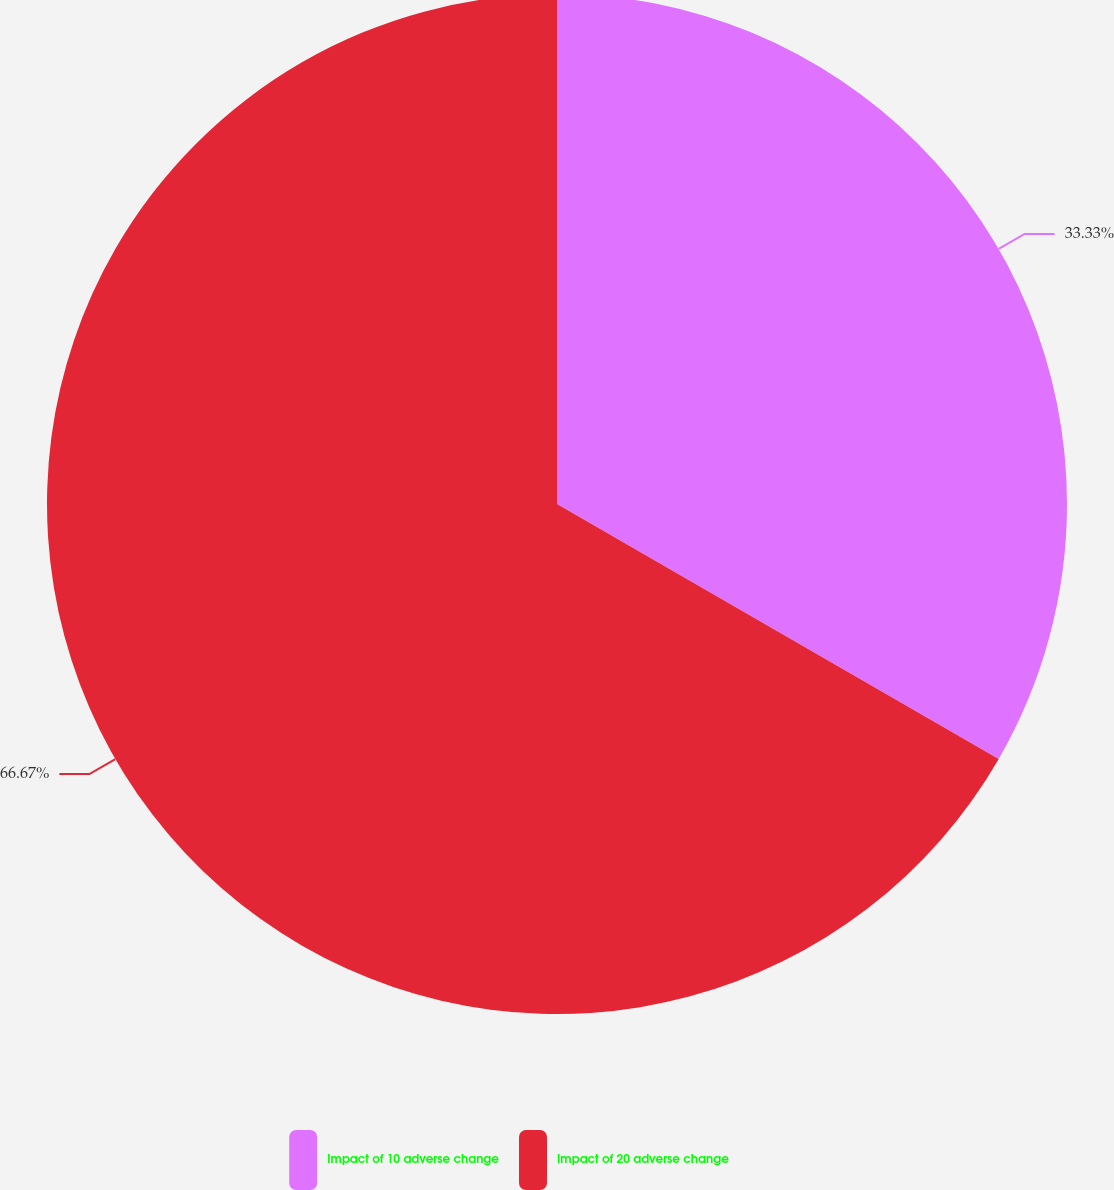<chart> <loc_0><loc_0><loc_500><loc_500><pie_chart><fcel>Impact of 10 adverse change<fcel>Impact of 20 adverse change<nl><fcel>33.33%<fcel>66.67%<nl></chart> 